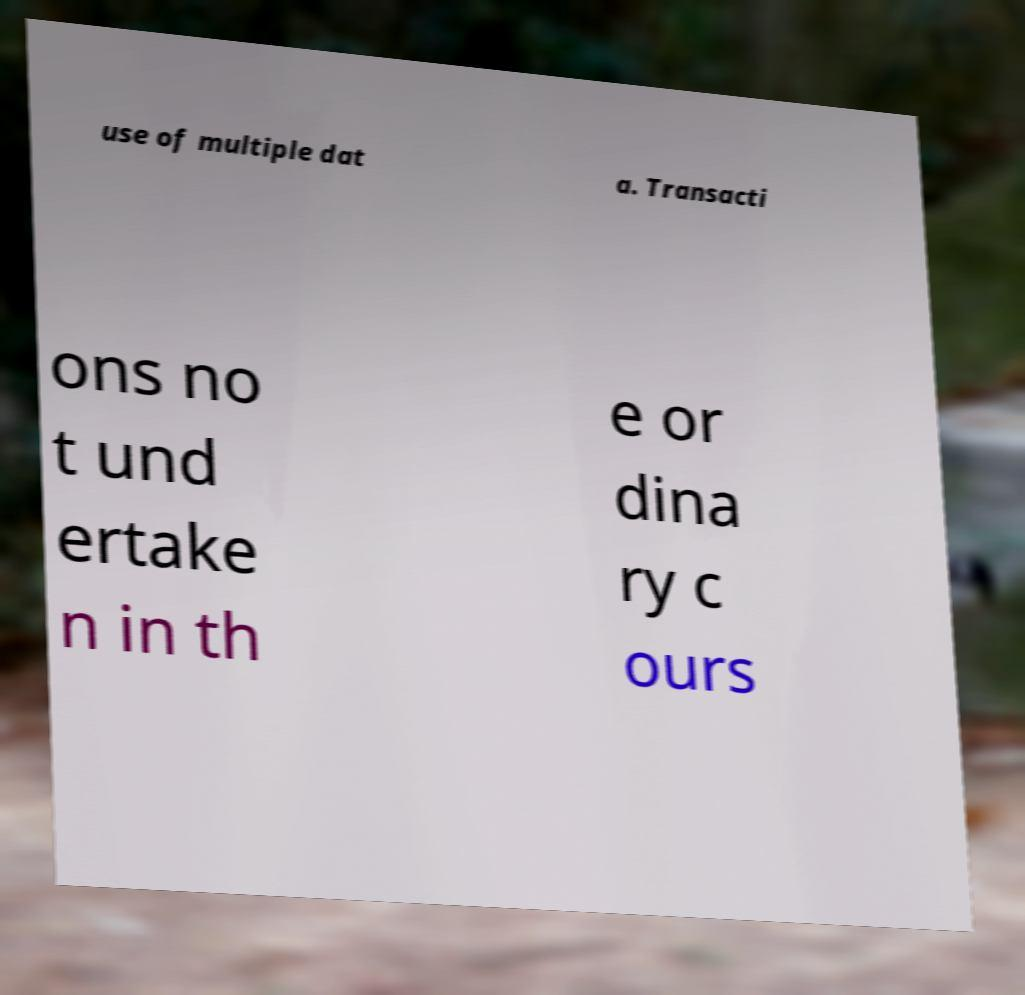Please identify and transcribe the text found in this image. use of multiple dat a. Transacti ons no t und ertake n in th e or dina ry c ours 